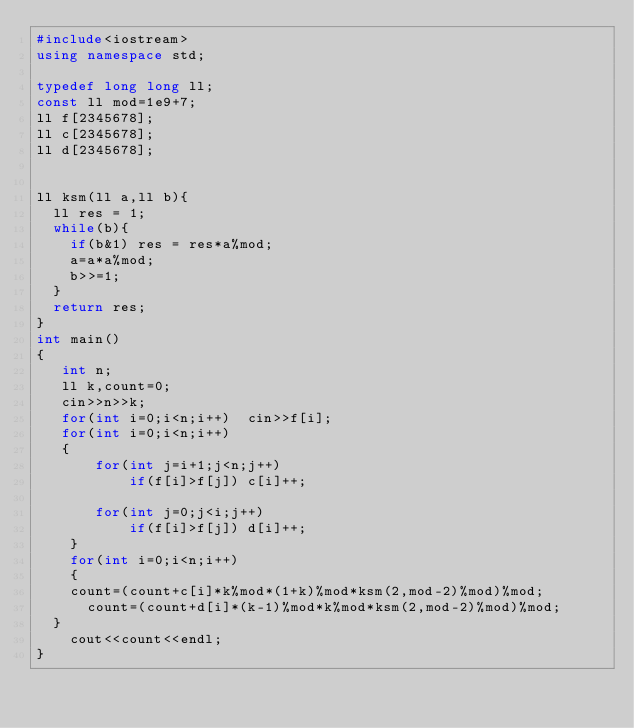<code> <loc_0><loc_0><loc_500><loc_500><_C++_>#include<iostream>
using namespace std;

typedef long long ll;
const ll mod=1e9+7;
ll f[2345678];
ll c[2345678];
ll d[2345678];


ll ksm(ll a,ll b){
	ll res = 1;
	while(b){
		if(b&1) res = res*a%mod;
		a=a*a%mod;
		b>>=1;
	}
	return res;
}
int main()
{
   int n;
   ll k,count=0;
   cin>>n>>k;
   for(int i=0;i<n;i++)  cin>>f[i];
   for(int i=0;i<n;i++)
   {
       for(int j=i+1;j<n;j++)
           if(f[i]>f[j]) c[i]++;
    
       for(int j=0;j<i;j++)
           if(f[i]>f[j]) d[i]++;
    }
    for(int i=0;i<n;i++)
    {    	
		count=(count+c[i]*k%mod*(1+k)%mod*ksm(2,mod-2)%mod)%mod;
    	count=(count+d[i]*(k-1)%mod*k%mod*ksm(2,mod-2)%mod)%mod;
	}
    cout<<count<<endl;
}</code> 